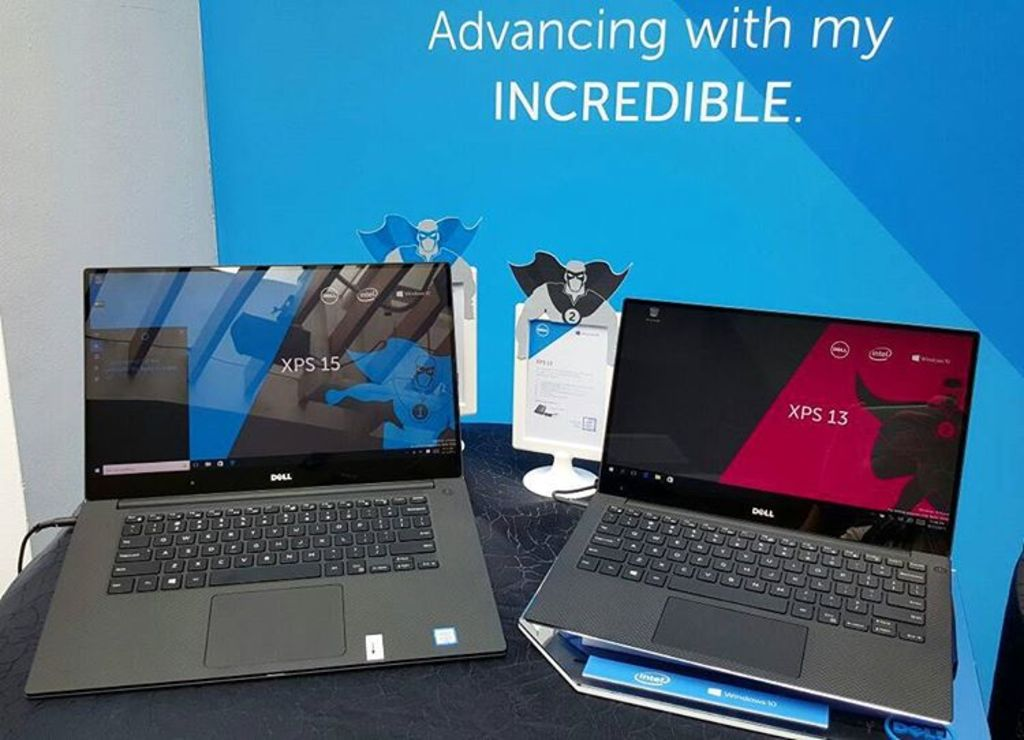What are the unique features of the Dell XPS 15 and XPS 13 laptops shown in this image? The Dell XPS 15 boasts a large, high-resolution screen ideal for professional graphics work, while the XPS 13 offers a more compact design suitable for on-the-go productivity with its impressive battery life and lightweight frame. 